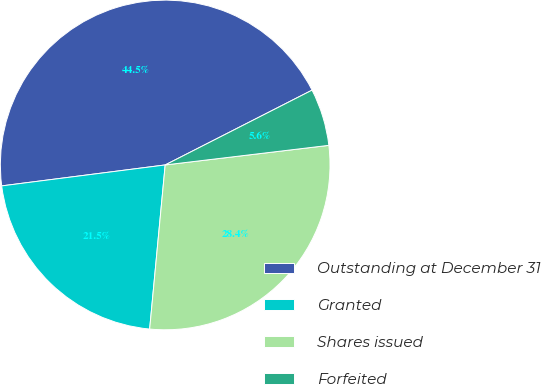<chart> <loc_0><loc_0><loc_500><loc_500><pie_chart><fcel>Outstanding at December 31<fcel>Granted<fcel>Shares issued<fcel>Forfeited<nl><fcel>44.53%<fcel>21.47%<fcel>28.4%<fcel>5.6%<nl></chart> 